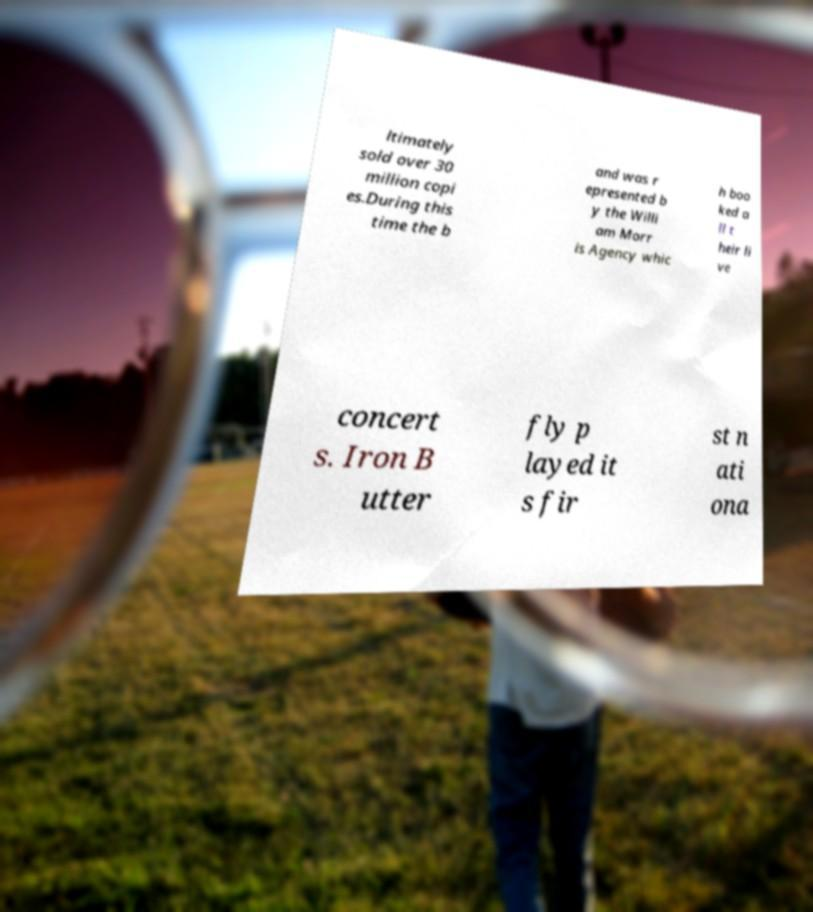Could you assist in decoding the text presented in this image and type it out clearly? ltimately sold over 30 million copi es.During this time the b and was r epresented b y the Willi am Morr is Agency whic h boo ked a ll t heir li ve concert s. Iron B utter fly p layed it s fir st n ati ona 